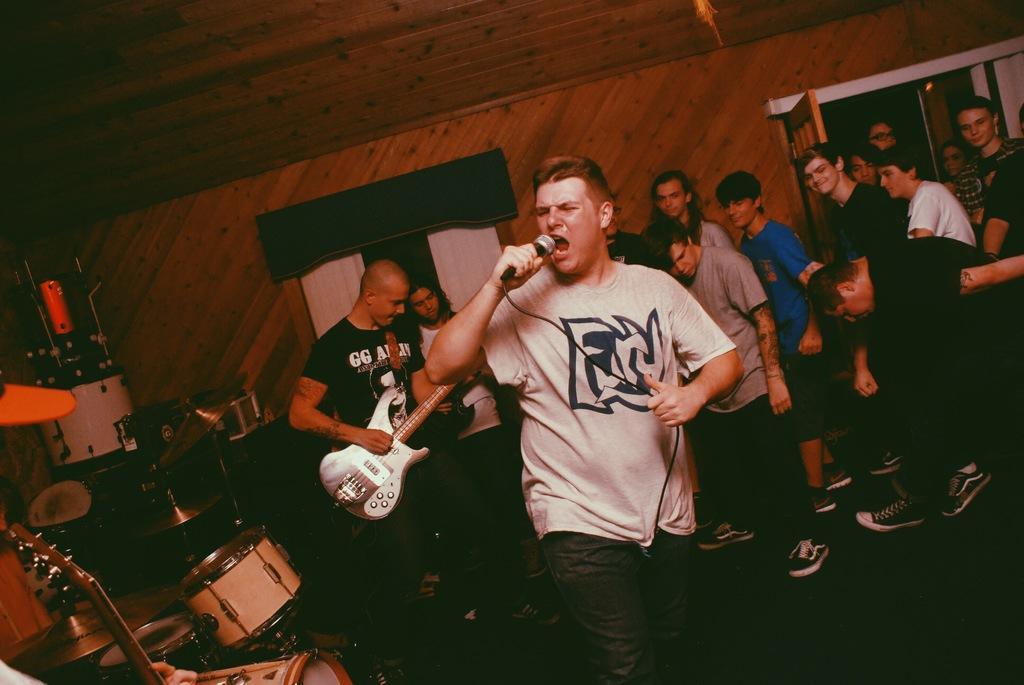Can you describe this image briefly? In this image I see a man who is holding the mic and I see another man who is holding a guitar and I see lot of people in the background and all of them are standing. I can also see few musical instruments over here and I see 2 windows and the wall. 